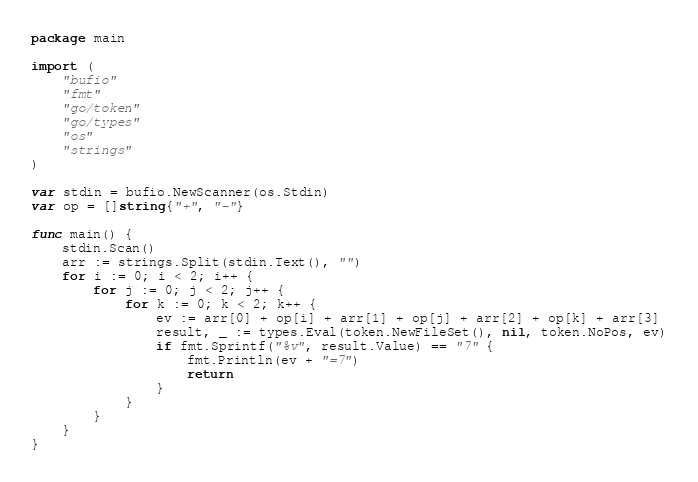Convert code to text. <code><loc_0><loc_0><loc_500><loc_500><_Go_>package main

import (
	"bufio"
	"fmt"
	"go/token"
	"go/types"
	"os"
	"strings"
)

var stdin = bufio.NewScanner(os.Stdin)
var op = []string{"+", "-"}

func main() {
	stdin.Scan()
	arr := strings.Split(stdin.Text(), "")
	for i := 0; i < 2; i++ {
		for j := 0; j < 2; j++ {
			for k := 0; k < 2; k++ {
				ev := arr[0] + op[i] + arr[1] + op[j] + arr[2] + op[k] + arr[3]
				result, _ := types.Eval(token.NewFileSet(), nil, token.NoPos, ev)
				if fmt.Sprintf("%v", result.Value) == "7" {
					fmt.Println(ev + "=7")
					return
				}
			}
		}
	}
}</code> 